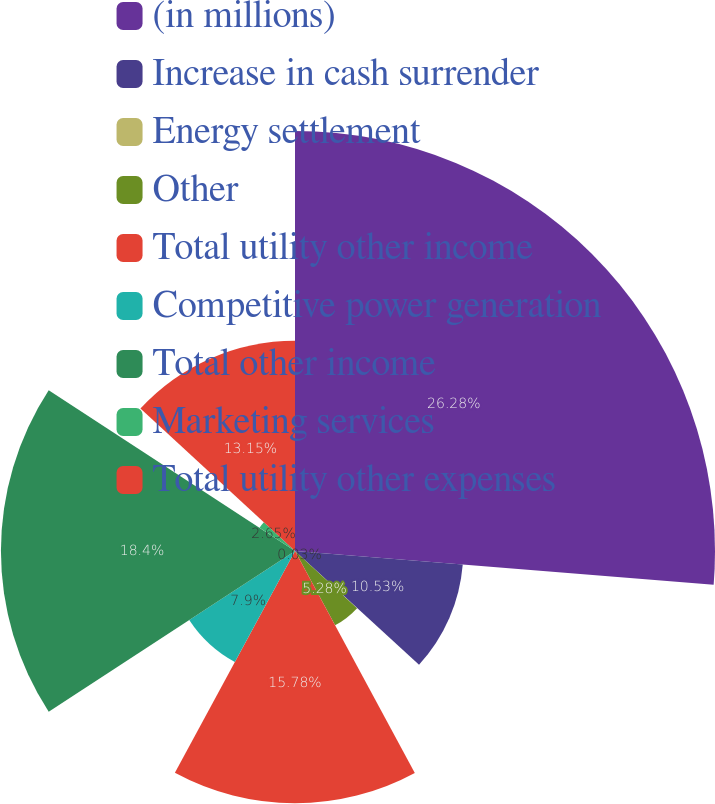Convert chart to OTSL. <chart><loc_0><loc_0><loc_500><loc_500><pie_chart><fcel>(in millions)<fcel>Increase in cash surrender<fcel>Energy settlement<fcel>Other<fcel>Total utility other income<fcel>Competitive power generation<fcel>Total other income<fcel>Marketing services<fcel>Total utility other expenses<nl><fcel>26.28%<fcel>10.53%<fcel>0.03%<fcel>5.28%<fcel>15.78%<fcel>7.9%<fcel>18.4%<fcel>2.65%<fcel>13.15%<nl></chart> 